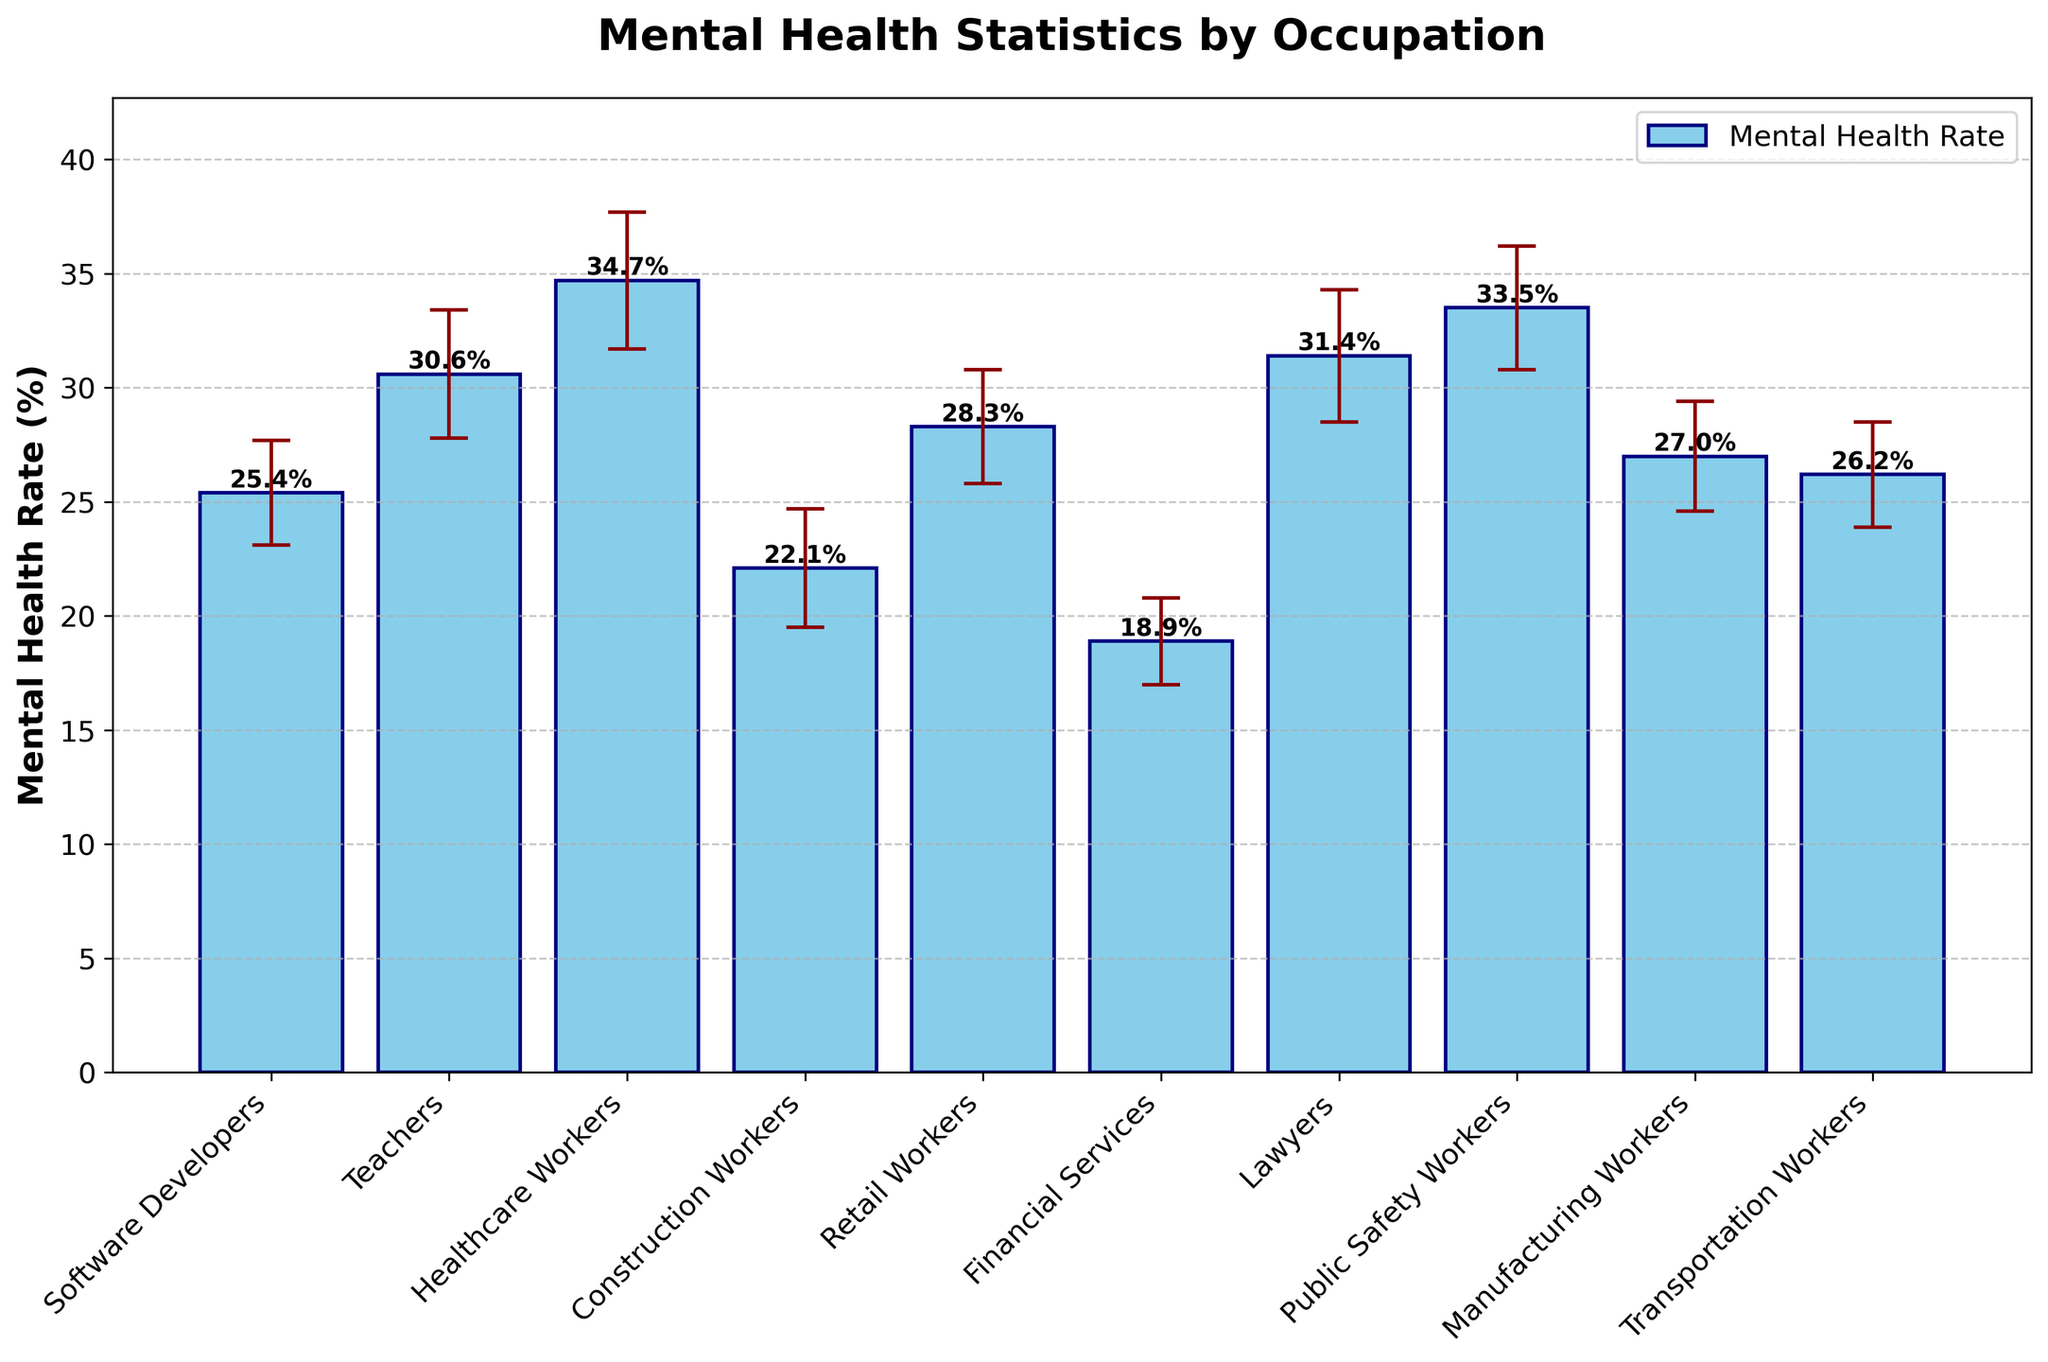Which occupation has the highest mental health rate? By examining the bar heights, the Healthcare Workers' bar is the tallest. This indicates that Healthcare Workers have the highest mental health rate.
Answer: Healthcare Workers What is the mental health rate for Software Developers? Looking at the specific bar labeled 'Software Developers,' its height indicates the mental health rate as approximately 25.4%.
Answer: 25.4% Which occupations have a mental health rate higher than 30%? By observing the bars that exceed the 30% mark on the y-axis, those occupations are Teachers, Healthcare Workers, Lawyers, and Public Safety Workers.
Answer: Teachers, Healthcare Workers, Lawyers, Public Safety Workers What is the difference in mental health rates between Lawyers and Financial Services workers? The mental health rate for Lawyers is 31.4%, and for Financial Services workers, it is 18.9%. Subtracting these values gives 31.4% - 18.9% = 12.5%.
Answer: 12.5% How do the error margins of Retail Workers and Construction Workers compare? Retail Workers have an error margin of 2.5%, and Construction Workers have an error margin of 2.6%. Comparing these figures shows that the error margin for Construction Workers is slightly higher.
Answer: Construction Workers' error margin is higher Which three occupations have the lowest mental health rates? By identifying the shortest bars, the occupations with the lowest mental health rates are Financial Services, Construction Workers, and Software Developers.
Answer: Financial Services, Construction Workers, Software Developers What is the combined mental health rate for Teachers and Public Safety Workers? The mental health rate for Teachers is 30.6%, and for Public Safety Workers, it is 33.5%. Adding these values gives 30.6% + 33.5% = 64.1%.
Answer: 64.1% Which occupation has a wider error margin, Teachers or Lawyers? Teachers have an error margin of 2.8%, and Lawyers have an error margin of 2.9%. Examining these values shows that Lawyers have a slightly wider error margin.
Answer: Lawyers What is the mid-range value of mental health rates for all occupations? The highest mental health rate is 34.7% (Healthcare Workers), and the lowest rate is 18.9% (Financial Services). The mid-range is calculated as (34.7% + 18.9%) / 2 = 26.8%.
Answer: 26.8% 